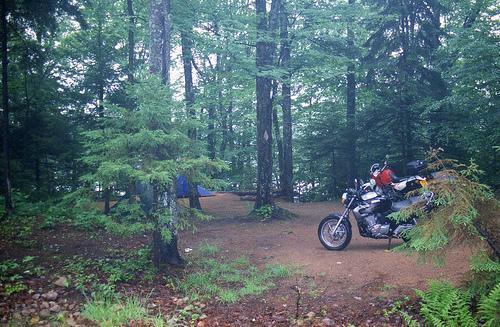How many motorcycles are visible?
Give a very brief answer. 1. How many red motorcycles are in the picture?
Give a very brief answer. 1. 